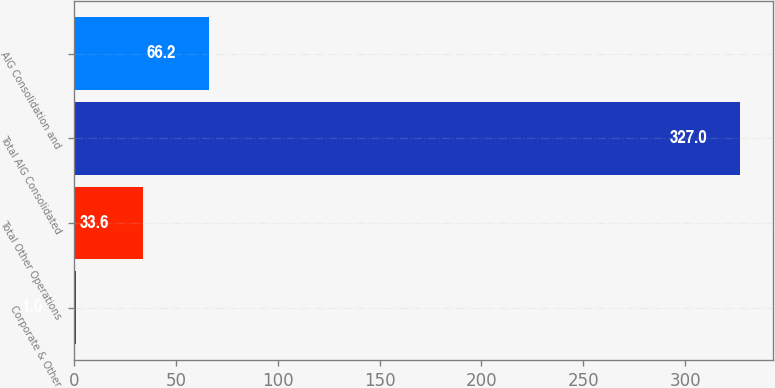Convert chart to OTSL. <chart><loc_0><loc_0><loc_500><loc_500><bar_chart><fcel>Corporate & Other<fcel>Total Other Operations<fcel>Total AIG Consolidated<fcel>AIG Consolidation and<nl><fcel>1<fcel>33.6<fcel>327<fcel>66.2<nl></chart> 